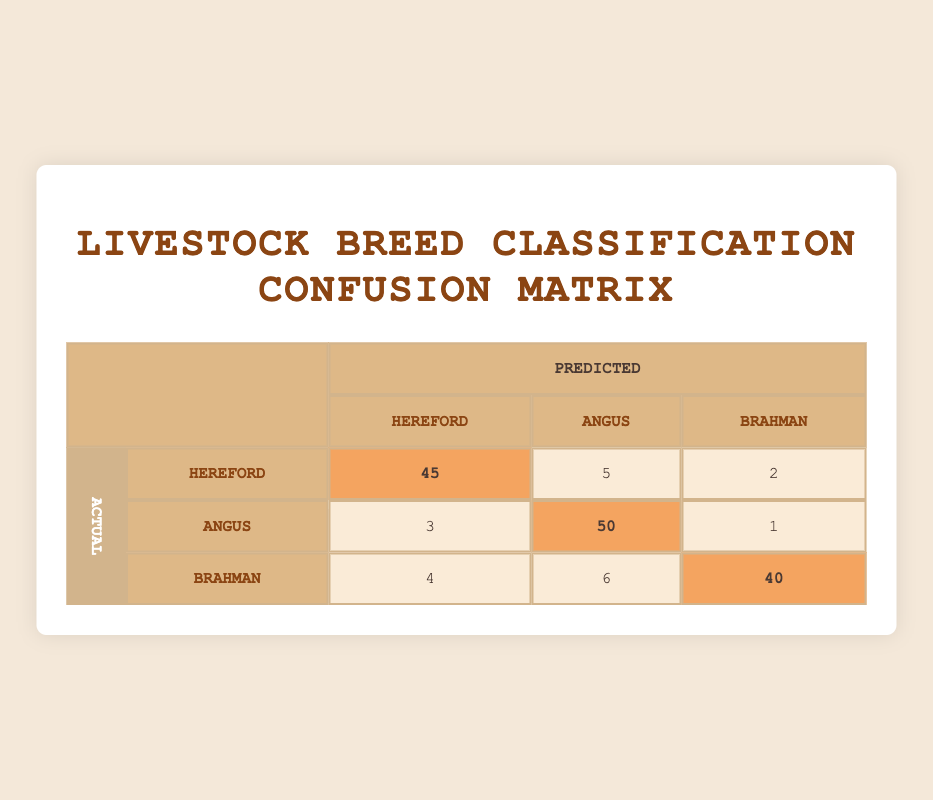What is the number of times Hereford was correctly classified? In the confusion matrix, the value for Hereford predicted as Hereford is 45. Therefore, the number of correct classifications for Hereford is 45.
Answer: 45 What is the total count of Angus livestock misclassified as Hereford? The value in the confusion matrix for Angus predicted as Hereford is 3, which indicates how many Angus were incorrectly classified.
Answer: 3 How many Brahman livestock were misclassified as Angus? The value in the confusion matrix for Brahman predicted as Angus is 6, representing the count of Brahman livestock that were incorrectly classified.
Answer: 6 What is the total number of livestock classified as Angus? Adding up the predicted values for Angus gives us 50 (correct) + 3 (Hereford misclassified) + 1 (Brahman misclassified) = 54. Therefore, the total classification count for Angus is 54.
Answer: 54 Are all animals classified correctly? By evaluating the diagonal values (Hereford as Hereford, Angus as Angus, Brahman as Brahman), there are multiple misclassifications indicated by the off-diagonal values. Therefore, not all animals are classified correctly.
Answer: No What is the total number of predictions made for Brahman? To find the total predictions for Brahman, we add the values: 40 (correct) + 4 (Hereford misclassified) + 6 (Angus misclassified) = 50. Thus, the total number of predictions for Brahman is 50.
Answer: 50 What percentage of predictions for Hereford were correct? To determine the percentage of correct predictions for Hereford: (correct predictions 45 / total predictions for Hereford (45 + 5 + 2 = 52)) * 100 = 86.54%. Thus, the percentage of correct predictions for Hereford is approximately 86.54%.
Answer: 86.54% Which breed had the highest number of correct predictions? For Hereford, correct predictions are 45; for Angus, they are 50; and for Brahman, they are 40. Angus has the highest count of correct predictions.
Answer: Angus 